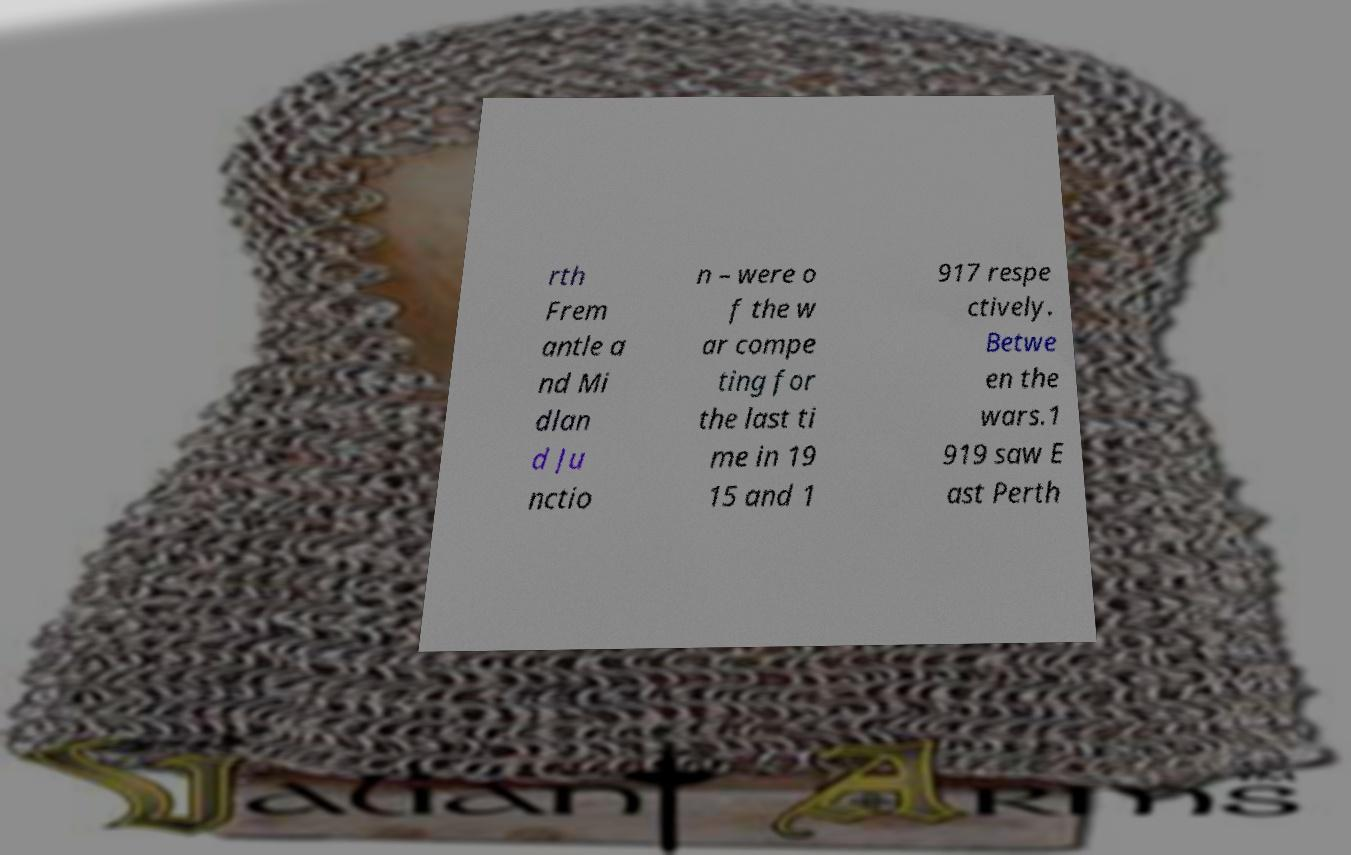I need the written content from this picture converted into text. Can you do that? rth Frem antle a nd Mi dlan d Ju nctio n – were o f the w ar compe ting for the last ti me in 19 15 and 1 917 respe ctively. Betwe en the wars.1 919 saw E ast Perth 